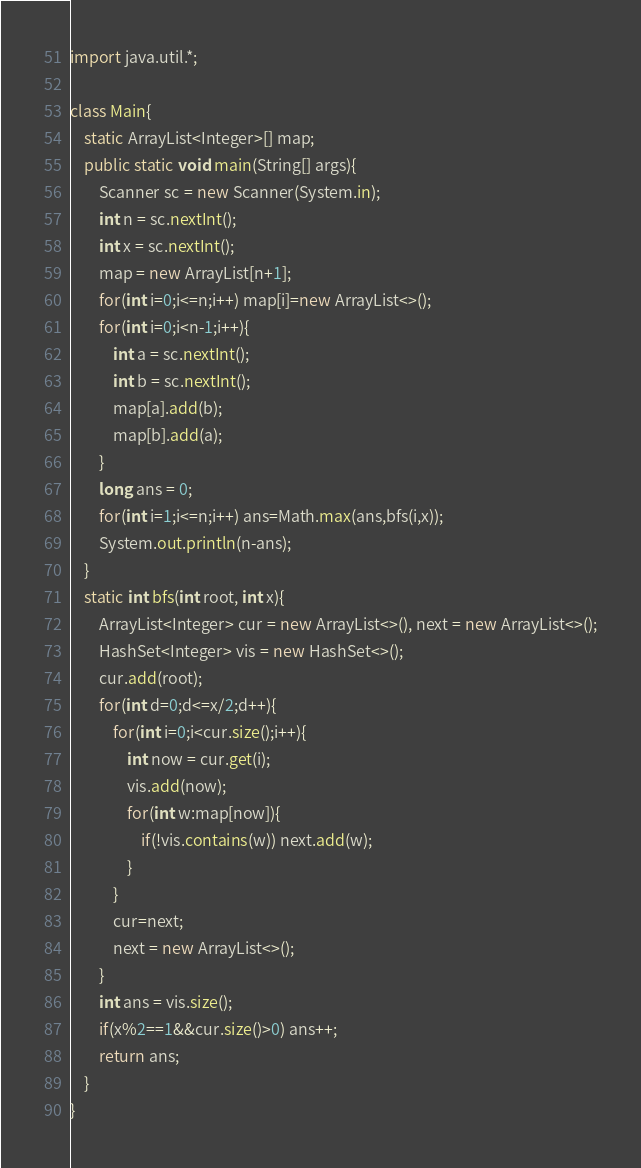<code> <loc_0><loc_0><loc_500><loc_500><_Java_>import java.util.*;

class Main{
    static ArrayList<Integer>[] map;
    public static void main(String[] args){
        Scanner sc = new Scanner(System.in);
        int n = sc.nextInt();
        int x = sc.nextInt();
        map = new ArrayList[n+1];
        for(int i=0;i<=n;i++) map[i]=new ArrayList<>();
        for(int i=0;i<n-1;i++){
            int a = sc.nextInt();
            int b = sc.nextInt();
            map[a].add(b);
            map[b].add(a);
        }
        long ans = 0;
        for(int i=1;i<=n;i++) ans=Math.max(ans,bfs(i,x));
        System.out.println(n-ans);
    }
    static int bfs(int root, int x){
        ArrayList<Integer> cur = new ArrayList<>(), next = new ArrayList<>();
        HashSet<Integer> vis = new HashSet<>();
        cur.add(root);
        for(int d=0;d<=x/2;d++){
            for(int i=0;i<cur.size();i++){
                int now = cur.get(i);
                vis.add(now);
                for(int w:map[now]){
                    if(!vis.contains(w)) next.add(w);
                }
            }
            cur=next;
            next = new ArrayList<>();
        }
        int ans = vis.size();
        if(x%2==1&&cur.size()>0) ans++;
        return ans;
    }
}
</code> 